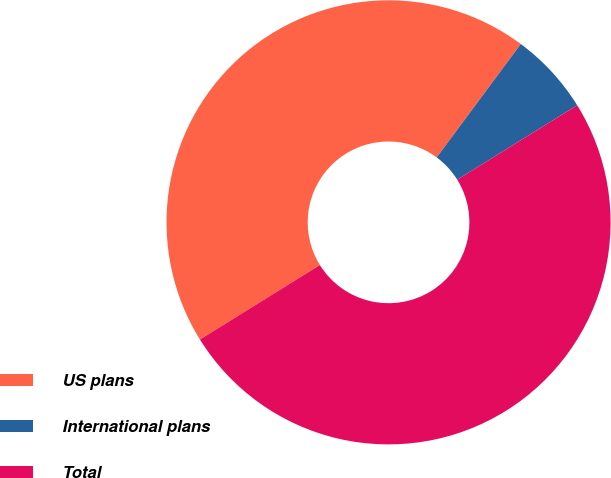Convert chart. <chart><loc_0><loc_0><loc_500><loc_500><pie_chart><fcel>US plans<fcel>International plans<fcel>Total<nl><fcel>44.0%<fcel>6.0%<fcel>50.0%<nl></chart> 